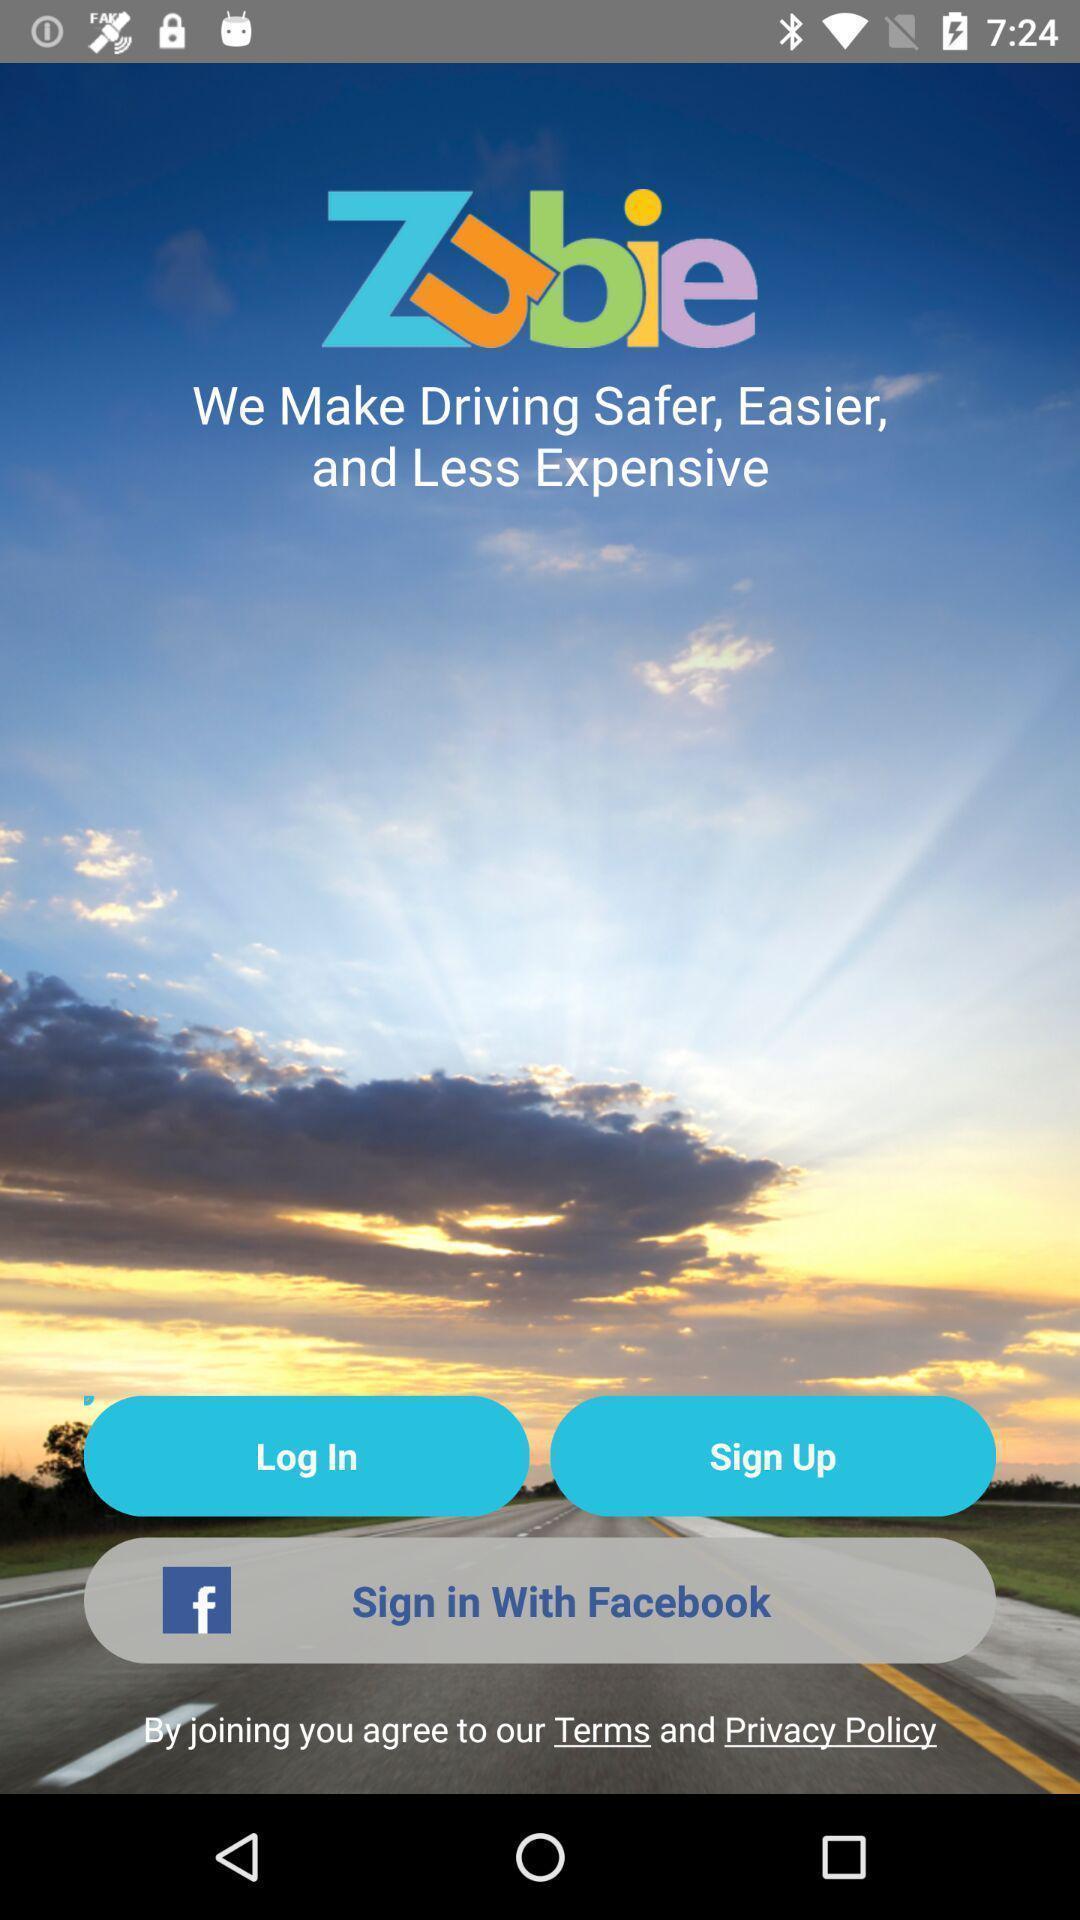What details can you identify in this image? Login page. 